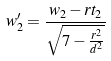Convert formula to latex. <formula><loc_0><loc_0><loc_500><loc_500>w _ { 2 } ^ { \prime } = \frac { w _ { 2 } - r t _ { 2 } } { \sqrt { 7 - \frac { r ^ { 2 } } { d ^ { 2 } } } }</formula> 